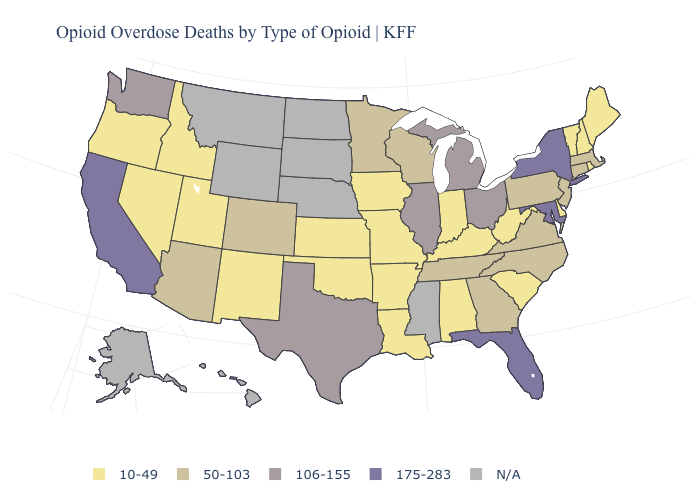Name the states that have a value in the range 50-103?
Short answer required. Arizona, Colorado, Connecticut, Georgia, Massachusetts, Minnesota, New Jersey, North Carolina, Pennsylvania, Tennessee, Virginia, Wisconsin. Does the map have missing data?
Short answer required. Yes. Name the states that have a value in the range 10-49?
Short answer required. Alabama, Arkansas, Delaware, Idaho, Indiana, Iowa, Kansas, Kentucky, Louisiana, Maine, Missouri, Nevada, New Hampshire, New Mexico, Oklahoma, Oregon, Rhode Island, South Carolina, Utah, Vermont, West Virginia. Which states hav the highest value in the Northeast?
Answer briefly. New York. Is the legend a continuous bar?
Answer briefly. No. How many symbols are there in the legend?
Be succinct. 5. Which states have the lowest value in the MidWest?
Write a very short answer. Indiana, Iowa, Kansas, Missouri. What is the highest value in the USA?
Short answer required. 175-283. How many symbols are there in the legend?
Quick response, please. 5. Which states have the lowest value in the West?
Answer briefly. Idaho, Nevada, New Mexico, Oregon, Utah. What is the value of Illinois?
Be succinct. 106-155. What is the highest value in the West ?
Concise answer only. 175-283. Among the states that border Idaho , does Nevada have the highest value?
Concise answer only. No. How many symbols are there in the legend?
Quick response, please. 5. 